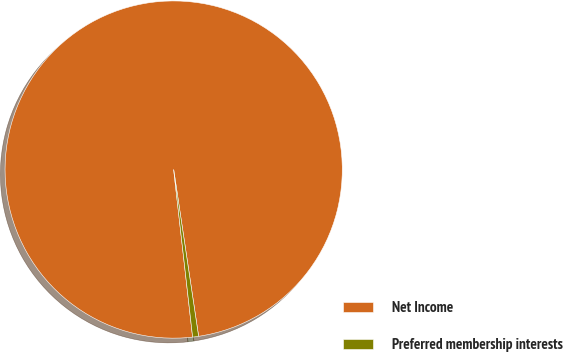Convert chart to OTSL. <chart><loc_0><loc_0><loc_500><loc_500><pie_chart><fcel>Net Income<fcel>Preferred membership interests<nl><fcel>99.43%<fcel>0.57%<nl></chart> 